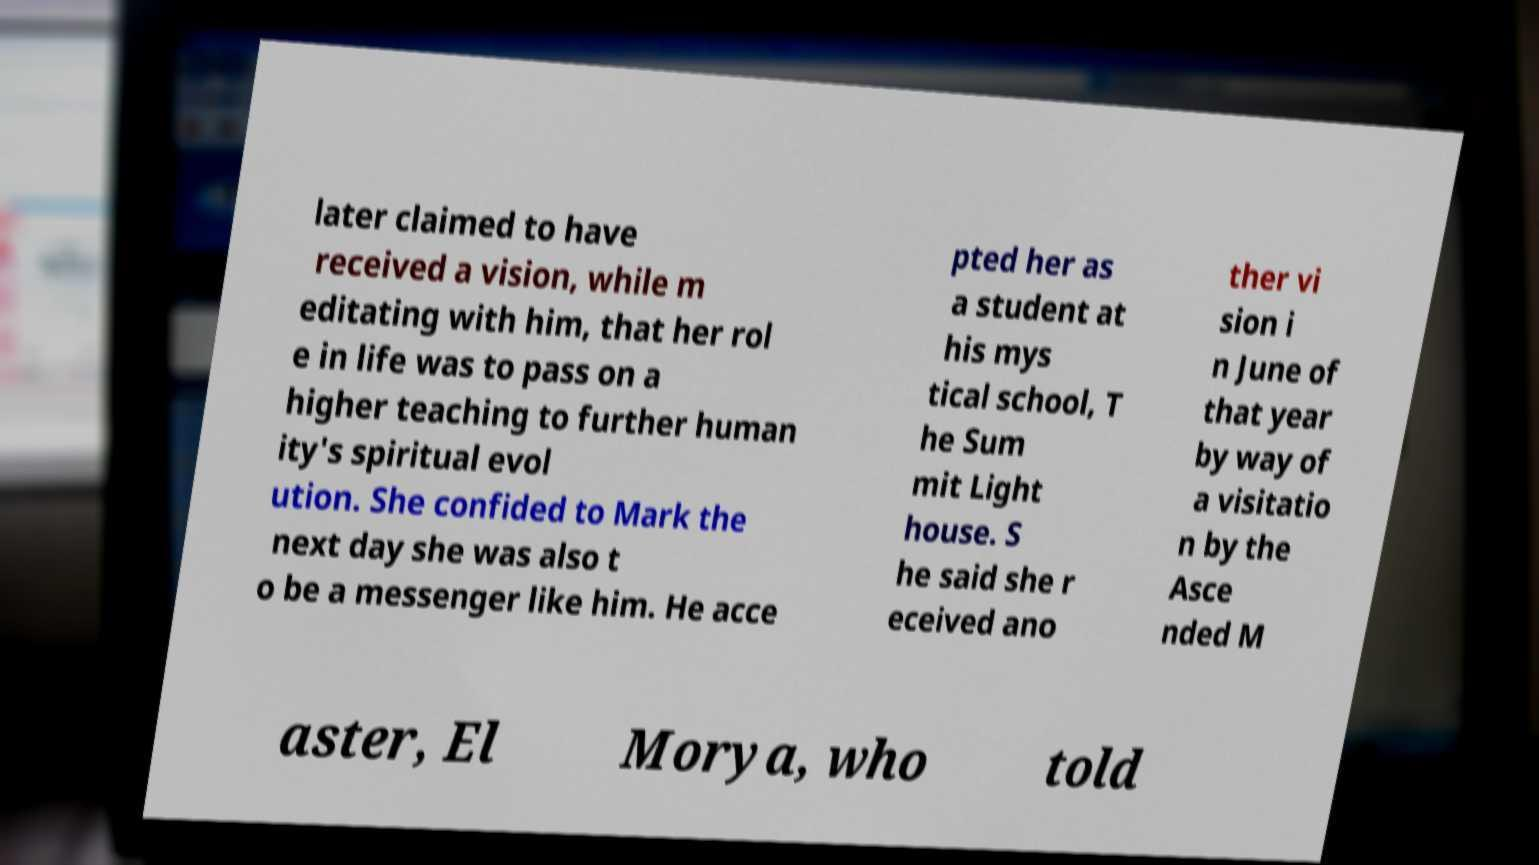Please identify and transcribe the text found in this image. later claimed to have received a vision, while m editating with him, that her rol e in life was to pass on a higher teaching to further human ity's spiritual evol ution. She confided to Mark the next day she was also t o be a messenger like him. He acce pted her as a student at his mys tical school, T he Sum mit Light house. S he said she r eceived ano ther vi sion i n June of that year by way of a visitatio n by the Asce nded M aster, El Morya, who told 